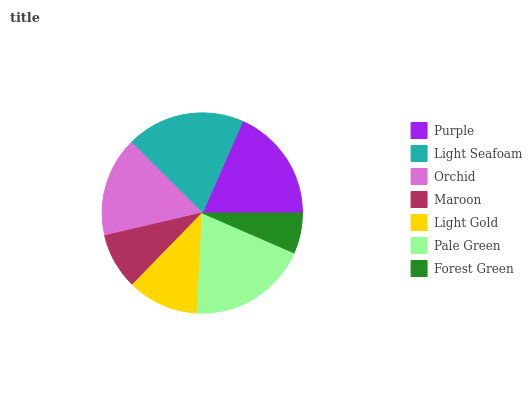Is Forest Green the minimum?
Answer yes or no. Yes. Is Pale Green the maximum?
Answer yes or no. Yes. Is Light Seafoam the minimum?
Answer yes or no. No. Is Light Seafoam the maximum?
Answer yes or no. No. Is Light Seafoam greater than Purple?
Answer yes or no. Yes. Is Purple less than Light Seafoam?
Answer yes or no. Yes. Is Purple greater than Light Seafoam?
Answer yes or no. No. Is Light Seafoam less than Purple?
Answer yes or no. No. Is Orchid the high median?
Answer yes or no. Yes. Is Orchid the low median?
Answer yes or no. Yes. Is Pale Green the high median?
Answer yes or no. No. Is Light Gold the low median?
Answer yes or no. No. 